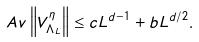<formula> <loc_0><loc_0><loc_500><loc_500>\ A v \left \| V _ { \Lambda _ { L } } ^ { \eta } \right \| \leq c L ^ { d - 1 } + b L ^ { d / 2 } .</formula> 